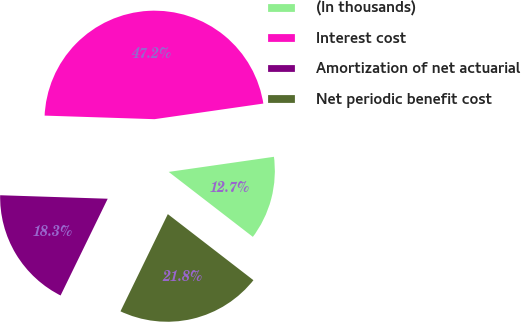Convert chart to OTSL. <chart><loc_0><loc_0><loc_500><loc_500><pie_chart><fcel>(In thousands)<fcel>Interest cost<fcel>Amortization of net actuarial<fcel>Net periodic benefit cost<nl><fcel>12.73%<fcel>47.21%<fcel>18.3%<fcel>21.75%<nl></chart> 